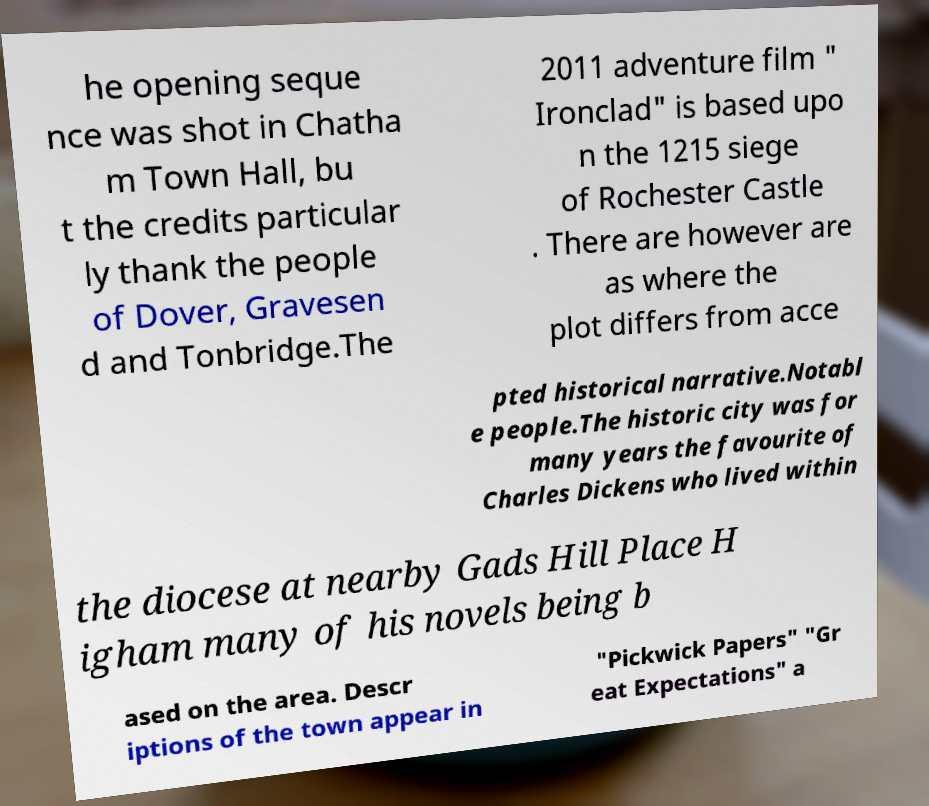I need the written content from this picture converted into text. Can you do that? he opening seque nce was shot in Chatha m Town Hall, bu t the credits particular ly thank the people of Dover, Gravesen d and Tonbridge.The 2011 adventure film " Ironclad" is based upo n the 1215 siege of Rochester Castle . There are however are as where the plot differs from acce pted historical narrative.Notabl e people.The historic city was for many years the favourite of Charles Dickens who lived within the diocese at nearby Gads Hill Place H igham many of his novels being b ased on the area. Descr iptions of the town appear in "Pickwick Papers" "Gr eat Expectations" a 